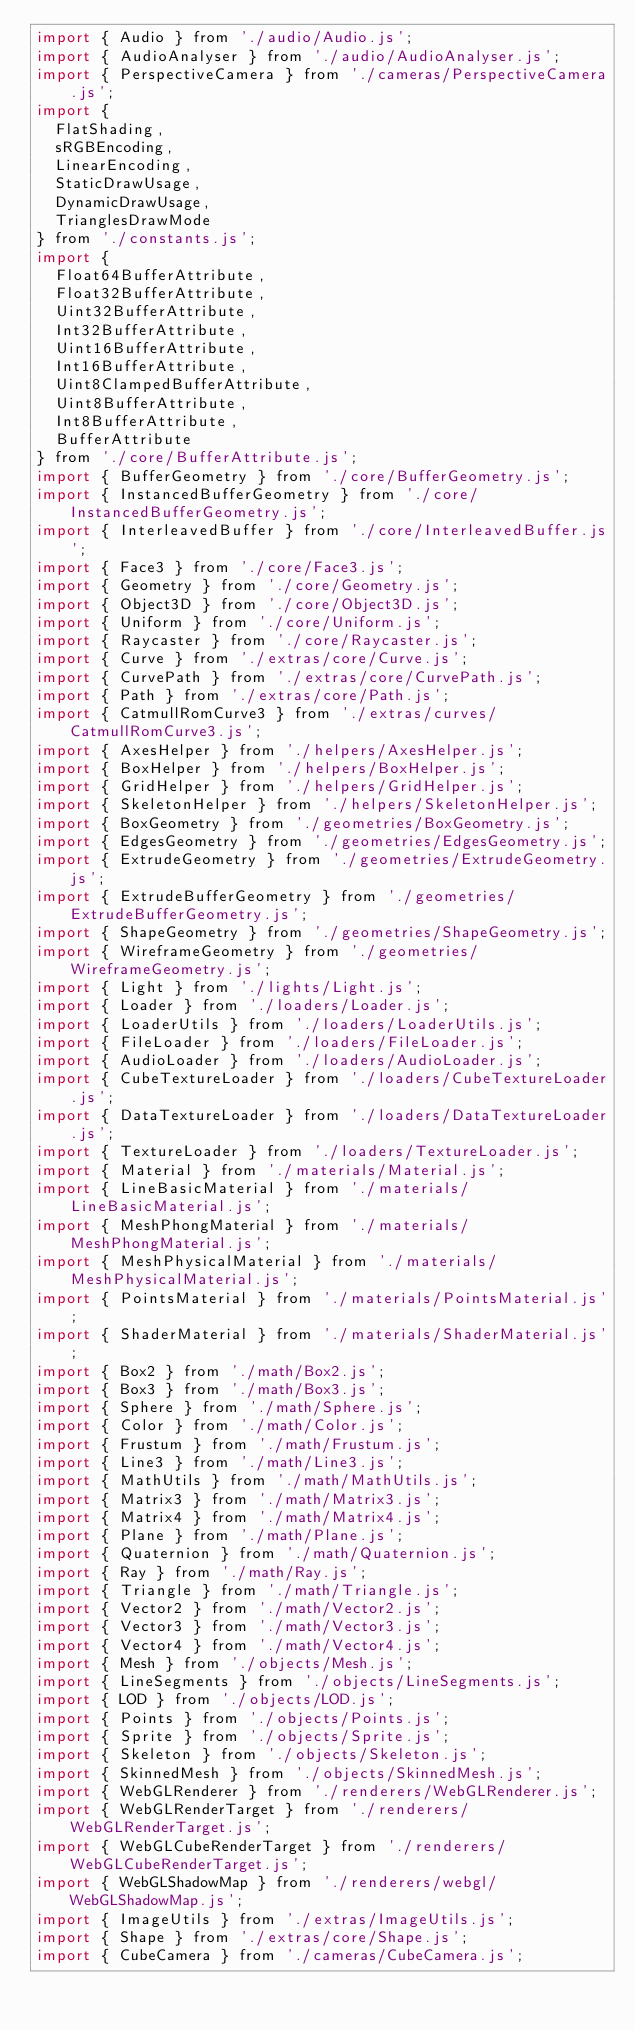<code> <loc_0><loc_0><loc_500><loc_500><_JavaScript_>import { Audio } from './audio/Audio.js';
import { AudioAnalyser } from './audio/AudioAnalyser.js';
import { PerspectiveCamera } from './cameras/PerspectiveCamera.js';
import {
	FlatShading,
	sRGBEncoding,
	LinearEncoding,
	StaticDrawUsage,
	DynamicDrawUsage,
	TrianglesDrawMode
} from './constants.js';
import {
	Float64BufferAttribute,
	Float32BufferAttribute,
	Uint32BufferAttribute,
	Int32BufferAttribute,
	Uint16BufferAttribute,
	Int16BufferAttribute,
	Uint8ClampedBufferAttribute,
	Uint8BufferAttribute,
	Int8BufferAttribute,
	BufferAttribute
} from './core/BufferAttribute.js';
import { BufferGeometry } from './core/BufferGeometry.js';
import { InstancedBufferGeometry } from './core/InstancedBufferGeometry.js';
import { InterleavedBuffer } from './core/InterleavedBuffer.js';
import { Face3 } from './core/Face3.js';
import { Geometry } from './core/Geometry.js';
import { Object3D } from './core/Object3D.js';
import { Uniform } from './core/Uniform.js';
import { Raycaster } from './core/Raycaster.js';
import { Curve } from './extras/core/Curve.js';
import { CurvePath } from './extras/core/CurvePath.js';
import { Path } from './extras/core/Path.js';
import { CatmullRomCurve3 } from './extras/curves/CatmullRomCurve3.js';
import { AxesHelper } from './helpers/AxesHelper.js';
import { BoxHelper } from './helpers/BoxHelper.js';
import { GridHelper } from './helpers/GridHelper.js';
import { SkeletonHelper } from './helpers/SkeletonHelper.js';
import { BoxGeometry } from './geometries/BoxGeometry.js';
import { EdgesGeometry } from './geometries/EdgesGeometry.js';
import { ExtrudeGeometry } from './geometries/ExtrudeGeometry.js';
import { ExtrudeBufferGeometry } from './geometries/ExtrudeBufferGeometry.js';
import { ShapeGeometry } from './geometries/ShapeGeometry.js';
import { WireframeGeometry } from './geometries/WireframeGeometry.js';
import { Light } from './lights/Light.js';
import { Loader } from './loaders/Loader.js';
import { LoaderUtils } from './loaders/LoaderUtils.js';
import { FileLoader } from './loaders/FileLoader.js';
import { AudioLoader } from './loaders/AudioLoader.js';
import { CubeTextureLoader } from './loaders/CubeTextureLoader.js';
import { DataTextureLoader } from './loaders/DataTextureLoader.js';
import { TextureLoader } from './loaders/TextureLoader.js';
import { Material } from './materials/Material.js';
import { LineBasicMaterial } from './materials/LineBasicMaterial.js';
import { MeshPhongMaterial } from './materials/MeshPhongMaterial.js';
import { MeshPhysicalMaterial } from './materials/MeshPhysicalMaterial.js';
import { PointsMaterial } from './materials/PointsMaterial.js';
import { ShaderMaterial } from './materials/ShaderMaterial.js';
import { Box2 } from './math/Box2.js';
import { Box3 } from './math/Box3.js';
import { Sphere } from './math/Sphere.js';
import { Color } from './math/Color.js';
import { Frustum } from './math/Frustum.js';
import { Line3 } from './math/Line3.js';
import { MathUtils } from './math/MathUtils.js';
import { Matrix3 } from './math/Matrix3.js';
import { Matrix4 } from './math/Matrix4.js';
import { Plane } from './math/Plane.js';
import { Quaternion } from './math/Quaternion.js';
import { Ray } from './math/Ray.js';
import { Triangle } from './math/Triangle.js';
import { Vector2 } from './math/Vector2.js';
import { Vector3 } from './math/Vector3.js';
import { Vector4 } from './math/Vector4.js';
import { Mesh } from './objects/Mesh.js';
import { LineSegments } from './objects/LineSegments.js';
import { LOD } from './objects/LOD.js';
import { Points } from './objects/Points.js';
import { Sprite } from './objects/Sprite.js';
import { Skeleton } from './objects/Skeleton.js';
import { SkinnedMesh } from './objects/SkinnedMesh.js';
import { WebGLRenderer } from './renderers/WebGLRenderer.js';
import { WebGLRenderTarget } from './renderers/WebGLRenderTarget.js';
import { WebGLCubeRenderTarget } from './renderers/WebGLCubeRenderTarget.js';
import { WebGLShadowMap } from './renderers/webgl/WebGLShadowMap.js';
import { ImageUtils } from './extras/ImageUtils.js';
import { Shape } from './extras/core/Shape.js';
import { CubeCamera } from './cameras/CubeCamera.js';</code> 